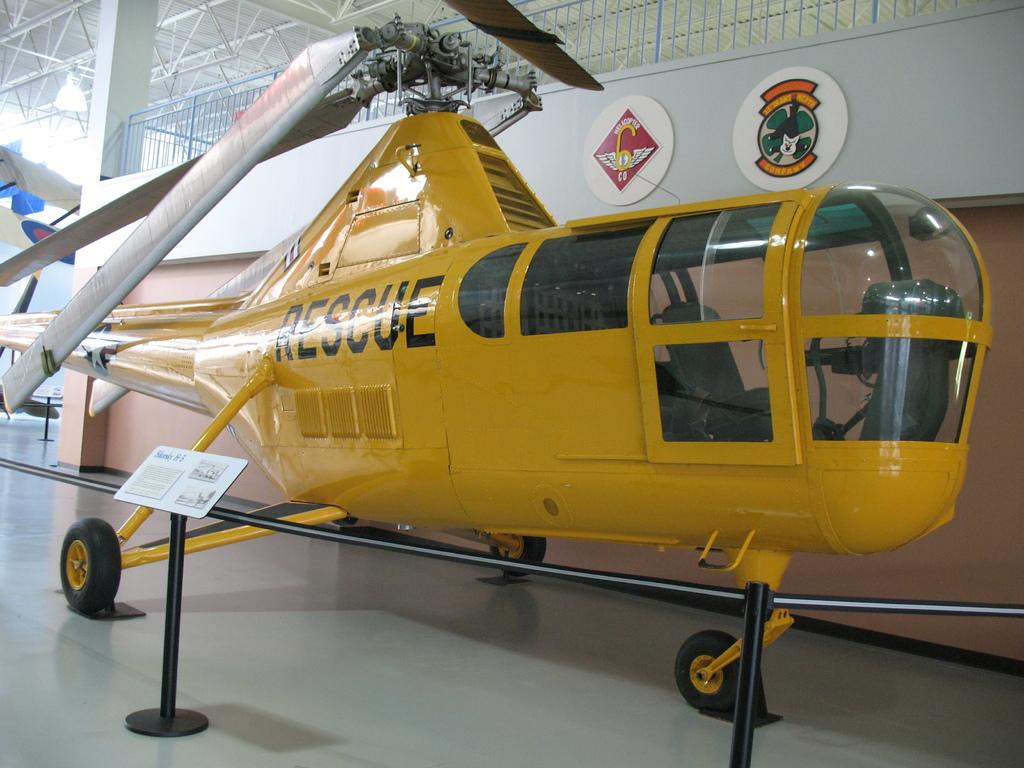<image>
Write a terse but informative summary of the picture. A yellow helicopter with the word Rescue on one side 